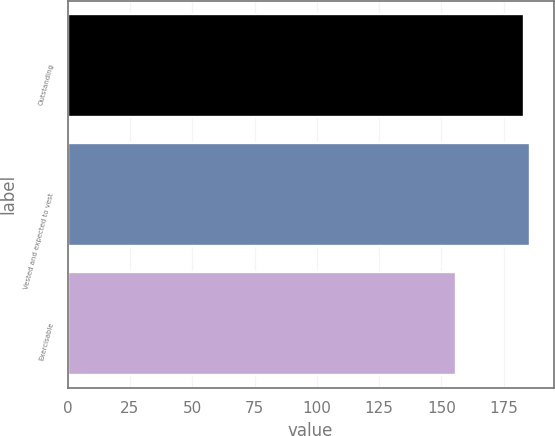Convert chart. <chart><loc_0><loc_0><loc_500><loc_500><bar_chart><fcel>Outstanding<fcel>Vested and expected to vest<fcel>Exercisable<nl><fcel>183<fcel>185.7<fcel>156<nl></chart> 